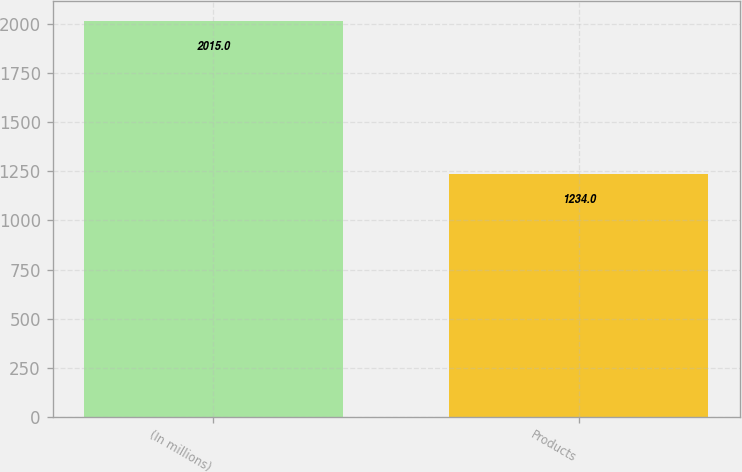Convert chart to OTSL. <chart><loc_0><loc_0><loc_500><loc_500><bar_chart><fcel>(In millions)<fcel>Products<nl><fcel>2015<fcel>1234<nl></chart> 